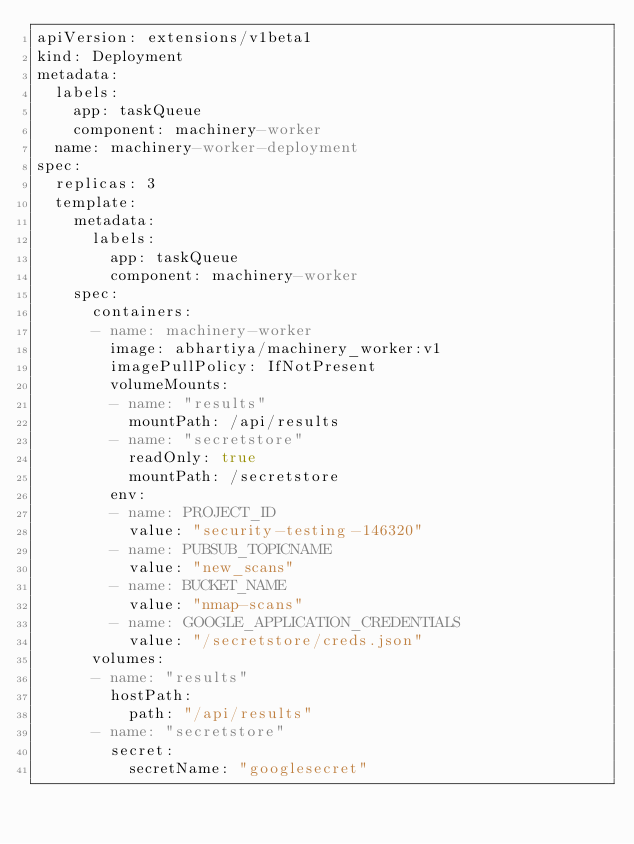Convert code to text. <code><loc_0><loc_0><loc_500><loc_500><_YAML_>apiVersion: extensions/v1beta1
kind: Deployment
metadata:
  labels: 
    app: taskQueue
    component: machinery-worker
  name: machinery-worker-deployment
spec:
  replicas: 3
  template:
    metadata:
      labels:
        app: taskQueue
        component: machinery-worker
    spec:
      containers:
      - name: machinery-worker
        image: abhartiya/machinery_worker:v1
        imagePullPolicy: IfNotPresent
        volumeMounts:
        - name: "results"
          mountPath: /api/results
        - name: "secretstore"
          readOnly: true
          mountPath: /secretstore
        env:
        - name: PROJECT_ID
          value: "security-testing-146320"
        - name: PUBSUB_TOPICNAME
          value: "new_scans"
        - name: BUCKET_NAME
          value: "nmap-scans"
        - name: GOOGLE_APPLICATION_CREDENTIALS
          value: "/secretstore/creds.json"
      volumes:
      - name: "results"
        hostPath: 
          path: "/api/results"
      - name: "secretstore"
        secret:
          secretName: "googlesecret"
</code> 